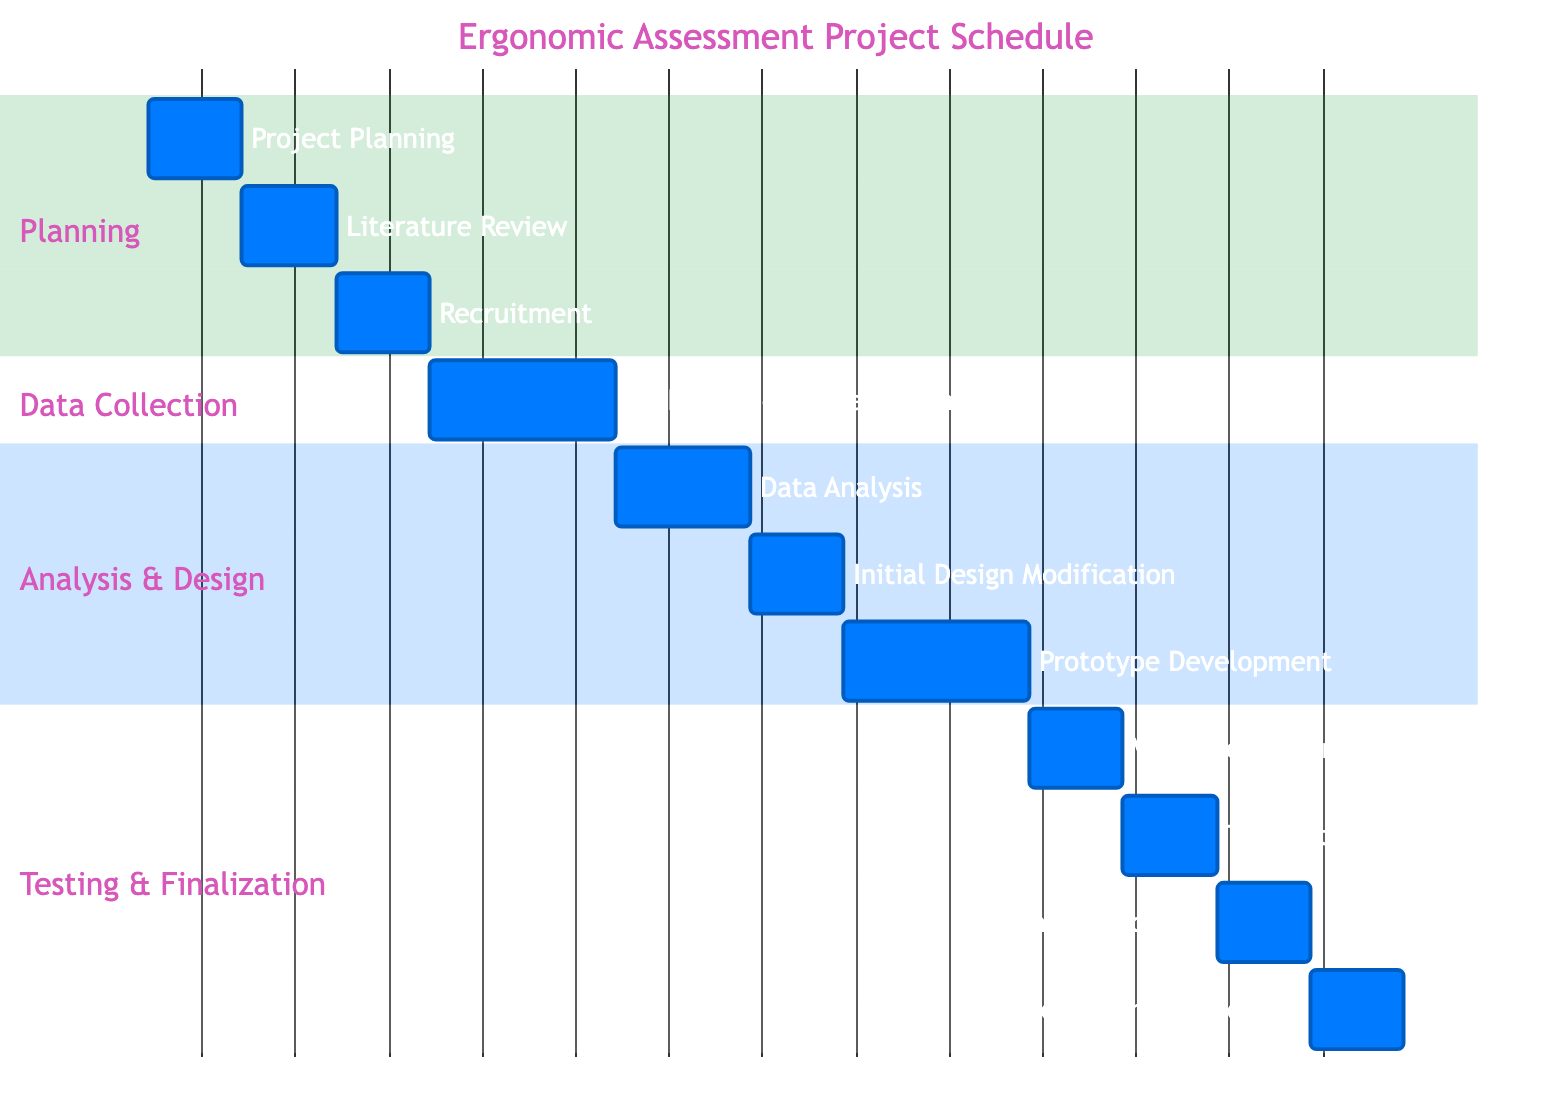What is the duration of the "Data Analysis and Interpretation" task? The "Data Analysis and Interpretation" task starts on December 6, 2023, and ends on December 15, 2023. The duration is calculated by taking the difference between the end and start dates, which is 10 days.
Answer: 10 days How many tasks are there in the "Testing & Finalization" section? In the "Testing & Finalization" section, there are four tasks: "Validation Testing," "Data Analysis of Validation Testing," "Final Design Modification," and "Project Documentation and Reporting." Thus, the count of tasks is four.
Answer: 4 What task follows "Initial Equipment Design Modification"? According to the dependencies, "Prototype Development" follows "Initial Equipment Design Modification," as it starts immediately after the completion of that task.
Answer: Prototype Development What is the start date of the "Validation Testing" task? The "Validation Testing" task begins on January 6, 2024. This is determined by looking at the scheduling information for that specific task in the diagram.
Answer: January 6, 2024 Which task has the longest duration in the project schedule? The task "Data Collection: Anthropometric Measurements" lasts for 14 days, which is the longest duration when comparing all tasks in the chart. The other tasks either last for 7 or 10 days.
Answer: 14 days How many tasks depend on the "Data Collection: Anthropometric Measurements"? The task "Data Analysis and Interpretation" is the only task that directly depends on "Data Collection: Anthropometric Measurements," meaning there is just one dependent task in the schedule.
Answer: 1 What is the overall duration of the project? The overall project starts on November 1, 2023, and ends on February 2, 2024. The total duration can be calculated by counting the days between these two dates, resulting in 93 days in total.
Answer: 93 days What task occurs immediately after the "Prototype Development"? "Validation Testing with Participants" occurs immediately after "Prototype Development," as demonstrated by the timeline in the Gantt chart where its start date is directly following that of "Prototype Development."
Answer: Validation Testing with Participants What is the end date of the "Literature Review and Requirement Gathering" task? The "Literature Review and Requirement Gathering" task ends on November 14, 2023. This can be confirmed by looking at its defined start and end dates in the project schedule.
Answer: November 14, 2023 